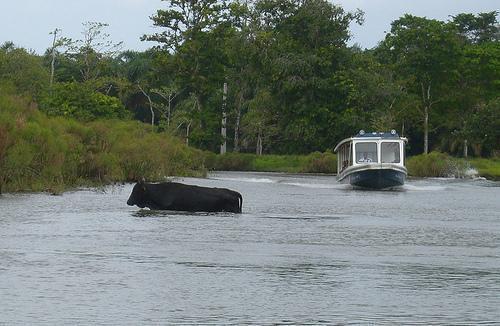How many animals are in the image?
Give a very brief answer. 1. How many tails does the animal have?
Give a very brief answer. 1. 